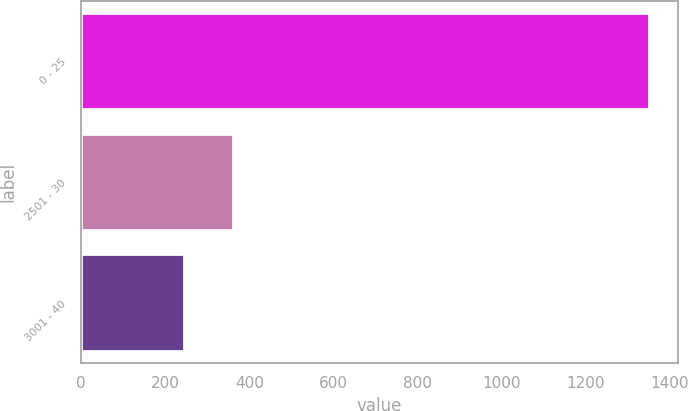Convert chart to OTSL. <chart><loc_0><loc_0><loc_500><loc_500><bar_chart><fcel>0 - 25<fcel>2501 - 30<fcel>3001 - 40<nl><fcel>1352<fcel>362<fcel>245<nl></chart> 